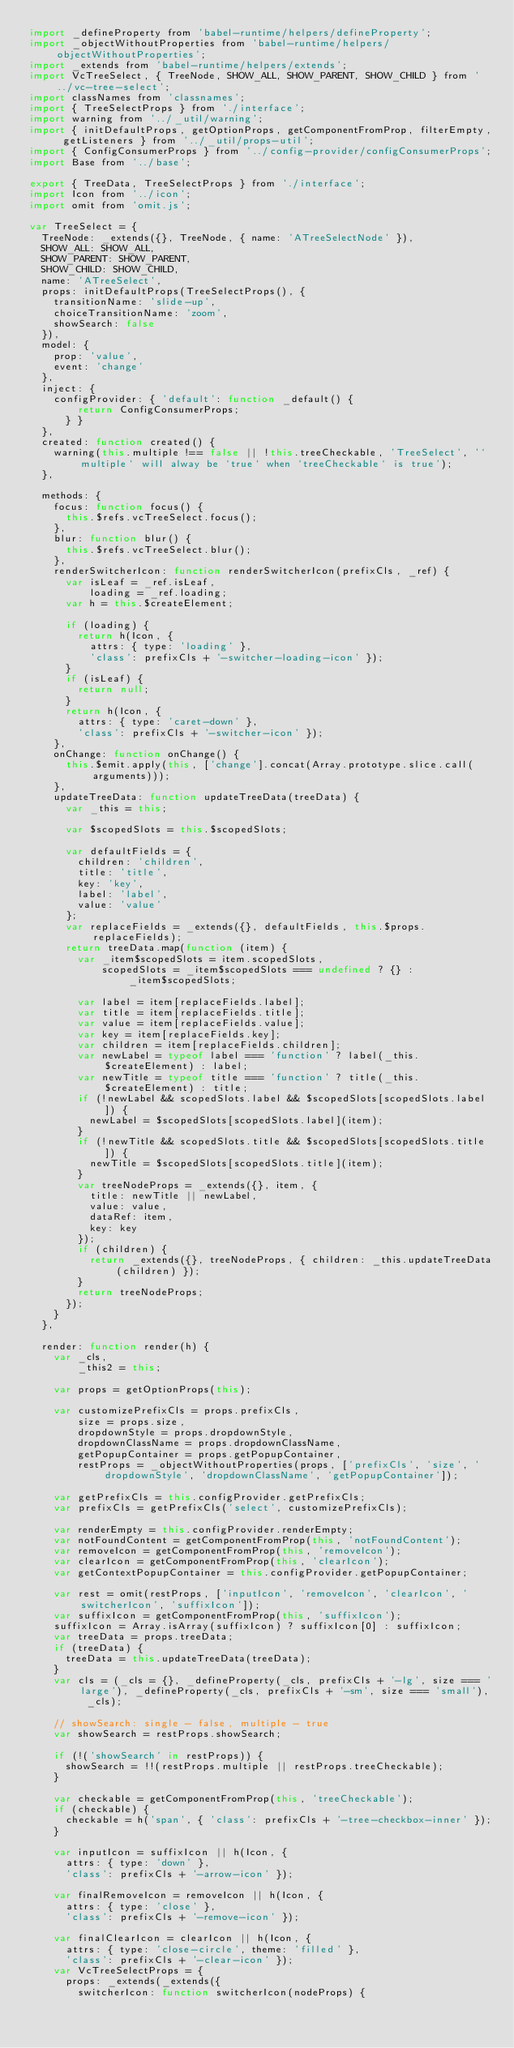<code> <loc_0><loc_0><loc_500><loc_500><_JavaScript_>import _defineProperty from 'babel-runtime/helpers/defineProperty';
import _objectWithoutProperties from 'babel-runtime/helpers/objectWithoutProperties';
import _extends from 'babel-runtime/helpers/extends';
import VcTreeSelect, { TreeNode, SHOW_ALL, SHOW_PARENT, SHOW_CHILD } from '../vc-tree-select';
import classNames from 'classnames';
import { TreeSelectProps } from './interface';
import warning from '../_util/warning';
import { initDefaultProps, getOptionProps, getComponentFromProp, filterEmpty, getListeners } from '../_util/props-util';
import { ConfigConsumerProps } from '../config-provider/configConsumerProps';
import Base from '../base';

export { TreeData, TreeSelectProps } from './interface';
import Icon from '../icon';
import omit from 'omit.js';

var TreeSelect = {
  TreeNode: _extends({}, TreeNode, { name: 'ATreeSelectNode' }),
  SHOW_ALL: SHOW_ALL,
  SHOW_PARENT: SHOW_PARENT,
  SHOW_CHILD: SHOW_CHILD,
  name: 'ATreeSelect',
  props: initDefaultProps(TreeSelectProps(), {
    transitionName: 'slide-up',
    choiceTransitionName: 'zoom',
    showSearch: false
  }),
  model: {
    prop: 'value',
    event: 'change'
  },
  inject: {
    configProvider: { 'default': function _default() {
        return ConfigConsumerProps;
      } }
  },
  created: function created() {
    warning(this.multiple !== false || !this.treeCheckable, 'TreeSelect', '`multiple` will alway be `true` when `treeCheckable` is true');
  },

  methods: {
    focus: function focus() {
      this.$refs.vcTreeSelect.focus();
    },
    blur: function blur() {
      this.$refs.vcTreeSelect.blur();
    },
    renderSwitcherIcon: function renderSwitcherIcon(prefixCls, _ref) {
      var isLeaf = _ref.isLeaf,
          loading = _ref.loading;
      var h = this.$createElement;

      if (loading) {
        return h(Icon, {
          attrs: { type: 'loading' },
          'class': prefixCls + '-switcher-loading-icon' });
      }
      if (isLeaf) {
        return null;
      }
      return h(Icon, {
        attrs: { type: 'caret-down' },
        'class': prefixCls + '-switcher-icon' });
    },
    onChange: function onChange() {
      this.$emit.apply(this, ['change'].concat(Array.prototype.slice.call(arguments)));
    },
    updateTreeData: function updateTreeData(treeData) {
      var _this = this;

      var $scopedSlots = this.$scopedSlots;

      var defaultFields = {
        children: 'children',
        title: 'title',
        key: 'key',
        label: 'label',
        value: 'value'
      };
      var replaceFields = _extends({}, defaultFields, this.$props.replaceFields);
      return treeData.map(function (item) {
        var _item$scopedSlots = item.scopedSlots,
            scopedSlots = _item$scopedSlots === undefined ? {} : _item$scopedSlots;

        var label = item[replaceFields.label];
        var title = item[replaceFields.title];
        var value = item[replaceFields.value];
        var key = item[replaceFields.key];
        var children = item[replaceFields.children];
        var newLabel = typeof label === 'function' ? label(_this.$createElement) : label;
        var newTitle = typeof title === 'function' ? title(_this.$createElement) : title;
        if (!newLabel && scopedSlots.label && $scopedSlots[scopedSlots.label]) {
          newLabel = $scopedSlots[scopedSlots.label](item);
        }
        if (!newTitle && scopedSlots.title && $scopedSlots[scopedSlots.title]) {
          newTitle = $scopedSlots[scopedSlots.title](item);
        }
        var treeNodeProps = _extends({}, item, {
          title: newTitle || newLabel,
          value: value,
          dataRef: item,
          key: key
        });
        if (children) {
          return _extends({}, treeNodeProps, { children: _this.updateTreeData(children) });
        }
        return treeNodeProps;
      });
    }
  },

  render: function render(h) {
    var _cls,
        _this2 = this;

    var props = getOptionProps(this);

    var customizePrefixCls = props.prefixCls,
        size = props.size,
        dropdownStyle = props.dropdownStyle,
        dropdownClassName = props.dropdownClassName,
        getPopupContainer = props.getPopupContainer,
        restProps = _objectWithoutProperties(props, ['prefixCls', 'size', 'dropdownStyle', 'dropdownClassName', 'getPopupContainer']);

    var getPrefixCls = this.configProvider.getPrefixCls;
    var prefixCls = getPrefixCls('select', customizePrefixCls);

    var renderEmpty = this.configProvider.renderEmpty;
    var notFoundContent = getComponentFromProp(this, 'notFoundContent');
    var removeIcon = getComponentFromProp(this, 'removeIcon');
    var clearIcon = getComponentFromProp(this, 'clearIcon');
    var getContextPopupContainer = this.configProvider.getPopupContainer;

    var rest = omit(restProps, ['inputIcon', 'removeIcon', 'clearIcon', 'switcherIcon', 'suffixIcon']);
    var suffixIcon = getComponentFromProp(this, 'suffixIcon');
    suffixIcon = Array.isArray(suffixIcon) ? suffixIcon[0] : suffixIcon;
    var treeData = props.treeData;
    if (treeData) {
      treeData = this.updateTreeData(treeData);
    }
    var cls = (_cls = {}, _defineProperty(_cls, prefixCls + '-lg', size === 'large'), _defineProperty(_cls, prefixCls + '-sm', size === 'small'), _cls);

    // showSearch: single - false, multiple - true
    var showSearch = restProps.showSearch;

    if (!('showSearch' in restProps)) {
      showSearch = !!(restProps.multiple || restProps.treeCheckable);
    }

    var checkable = getComponentFromProp(this, 'treeCheckable');
    if (checkable) {
      checkable = h('span', { 'class': prefixCls + '-tree-checkbox-inner' });
    }

    var inputIcon = suffixIcon || h(Icon, {
      attrs: { type: 'down' },
      'class': prefixCls + '-arrow-icon' });

    var finalRemoveIcon = removeIcon || h(Icon, {
      attrs: { type: 'close' },
      'class': prefixCls + '-remove-icon' });

    var finalClearIcon = clearIcon || h(Icon, {
      attrs: { type: 'close-circle', theme: 'filled' },
      'class': prefixCls + '-clear-icon' });
    var VcTreeSelectProps = {
      props: _extends(_extends({
        switcherIcon: function switcherIcon(nodeProps) {</code> 